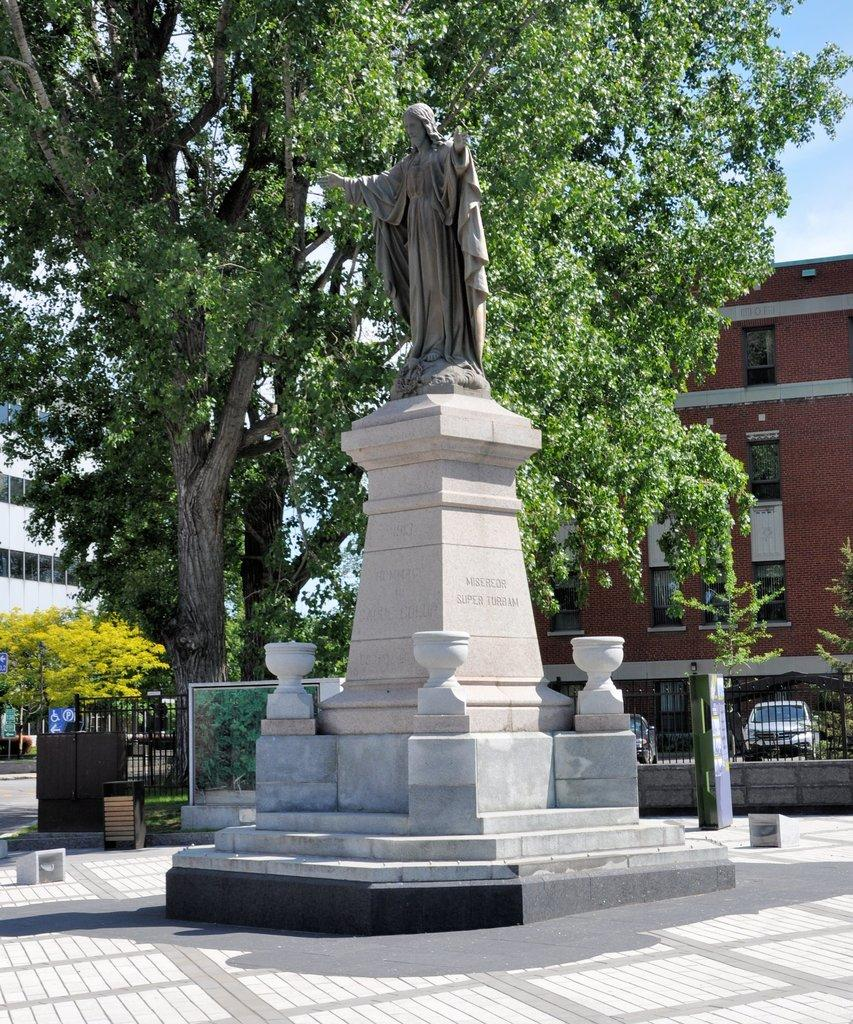What is the main subject in the center of the image? There is a statue in the center of the image. What is located behind the statue? There is a metal fence behind the statue. What type of vehicles can be seen in the image? Cars are visible in the image. What can be seen in the background of the image? Trees, buildings, and the sky are visible in the background of the image. What is the rate of the country's economic growth in the image? There is no information about the country's economic growth or any rates in the image; it features a statue, a metal fence, cars, trees, buildings, and the sky. 